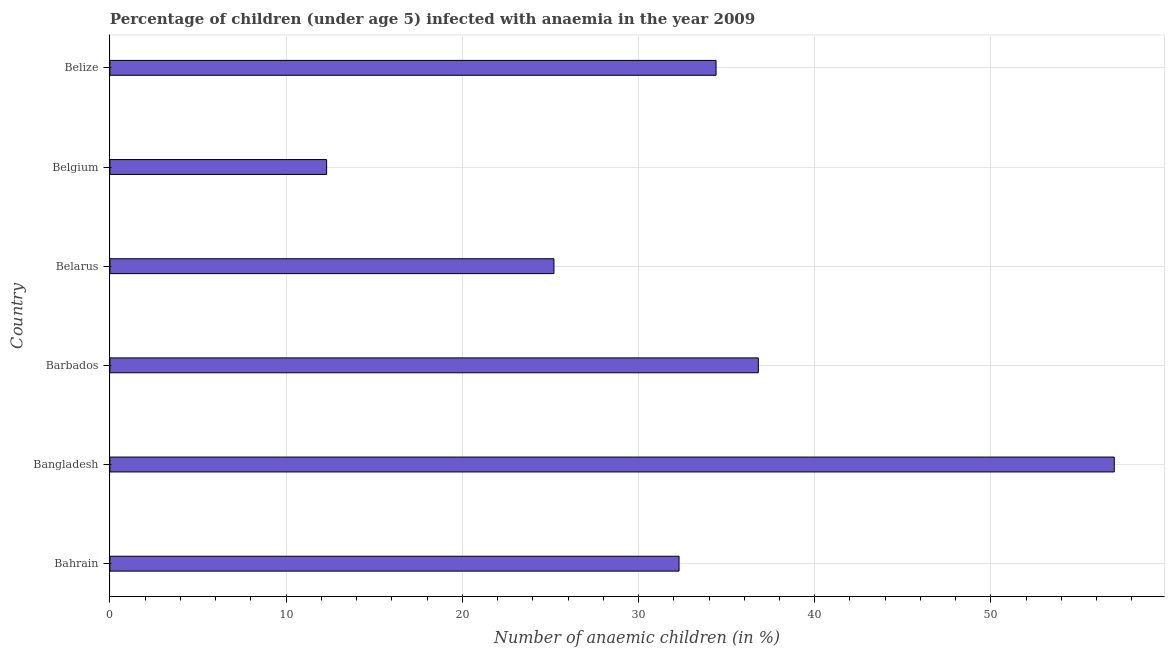Does the graph contain any zero values?
Give a very brief answer. No. What is the title of the graph?
Your answer should be compact. Percentage of children (under age 5) infected with anaemia in the year 2009. What is the label or title of the X-axis?
Your answer should be very brief. Number of anaemic children (in %). What is the label or title of the Y-axis?
Offer a very short reply. Country. What is the number of anaemic children in Barbados?
Keep it short and to the point. 36.8. Across all countries, what is the maximum number of anaemic children?
Ensure brevity in your answer.  57. Across all countries, what is the minimum number of anaemic children?
Your response must be concise. 12.3. What is the sum of the number of anaemic children?
Provide a succinct answer. 198. What is the difference between the number of anaemic children in Bangladesh and Belize?
Provide a succinct answer. 22.6. What is the median number of anaemic children?
Your answer should be very brief. 33.35. What is the ratio of the number of anaemic children in Barbados to that in Belize?
Provide a short and direct response. 1.07. What is the difference between the highest and the second highest number of anaemic children?
Make the answer very short. 20.2. Is the sum of the number of anaemic children in Bahrain and Belarus greater than the maximum number of anaemic children across all countries?
Offer a very short reply. Yes. What is the difference between the highest and the lowest number of anaemic children?
Provide a short and direct response. 44.7. How many bars are there?
Make the answer very short. 6. Are all the bars in the graph horizontal?
Your response must be concise. Yes. How many countries are there in the graph?
Your response must be concise. 6. What is the difference between two consecutive major ticks on the X-axis?
Keep it short and to the point. 10. Are the values on the major ticks of X-axis written in scientific E-notation?
Your answer should be very brief. No. What is the Number of anaemic children (in %) of Bahrain?
Give a very brief answer. 32.3. What is the Number of anaemic children (in %) in Barbados?
Offer a very short reply. 36.8. What is the Number of anaemic children (in %) of Belarus?
Your answer should be very brief. 25.2. What is the Number of anaemic children (in %) of Belgium?
Offer a very short reply. 12.3. What is the Number of anaemic children (in %) in Belize?
Ensure brevity in your answer.  34.4. What is the difference between the Number of anaemic children (in %) in Bahrain and Bangladesh?
Provide a short and direct response. -24.7. What is the difference between the Number of anaemic children (in %) in Bahrain and Belgium?
Provide a succinct answer. 20. What is the difference between the Number of anaemic children (in %) in Bangladesh and Barbados?
Provide a succinct answer. 20.2. What is the difference between the Number of anaemic children (in %) in Bangladesh and Belarus?
Provide a succinct answer. 31.8. What is the difference between the Number of anaemic children (in %) in Bangladesh and Belgium?
Provide a succinct answer. 44.7. What is the difference between the Number of anaemic children (in %) in Bangladesh and Belize?
Your answer should be very brief. 22.6. What is the difference between the Number of anaemic children (in %) in Barbados and Belarus?
Give a very brief answer. 11.6. What is the difference between the Number of anaemic children (in %) in Barbados and Belgium?
Ensure brevity in your answer.  24.5. What is the difference between the Number of anaemic children (in %) in Belarus and Belize?
Provide a short and direct response. -9.2. What is the difference between the Number of anaemic children (in %) in Belgium and Belize?
Make the answer very short. -22.1. What is the ratio of the Number of anaemic children (in %) in Bahrain to that in Bangladesh?
Provide a short and direct response. 0.57. What is the ratio of the Number of anaemic children (in %) in Bahrain to that in Barbados?
Your answer should be very brief. 0.88. What is the ratio of the Number of anaemic children (in %) in Bahrain to that in Belarus?
Your response must be concise. 1.28. What is the ratio of the Number of anaemic children (in %) in Bahrain to that in Belgium?
Offer a very short reply. 2.63. What is the ratio of the Number of anaemic children (in %) in Bahrain to that in Belize?
Keep it short and to the point. 0.94. What is the ratio of the Number of anaemic children (in %) in Bangladesh to that in Barbados?
Make the answer very short. 1.55. What is the ratio of the Number of anaemic children (in %) in Bangladesh to that in Belarus?
Offer a terse response. 2.26. What is the ratio of the Number of anaemic children (in %) in Bangladesh to that in Belgium?
Your answer should be compact. 4.63. What is the ratio of the Number of anaemic children (in %) in Bangladesh to that in Belize?
Provide a succinct answer. 1.66. What is the ratio of the Number of anaemic children (in %) in Barbados to that in Belarus?
Your answer should be very brief. 1.46. What is the ratio of the Number of anaemic children (in %) in Barbados to that in Belgium?
Make the answer very short. 2.99. What is the ratio of the Number of anaemic children (in %) in Barbados to that in Belize?
Provide a succinct answer. 1.07. What is the ratio of the Number of anaemic children (in %) in Belarus to that in Belgium?
Give a very brief answer. 2.05. What is the ratio of the Number of anaemic children (in %) in Belarus to that in Belize?
Offer a very short reply. 0.73. What is the ratio of the Number of anaemic children (in %) in Belgium to that in Belize?
Provide a succinct answer. 0.36. 